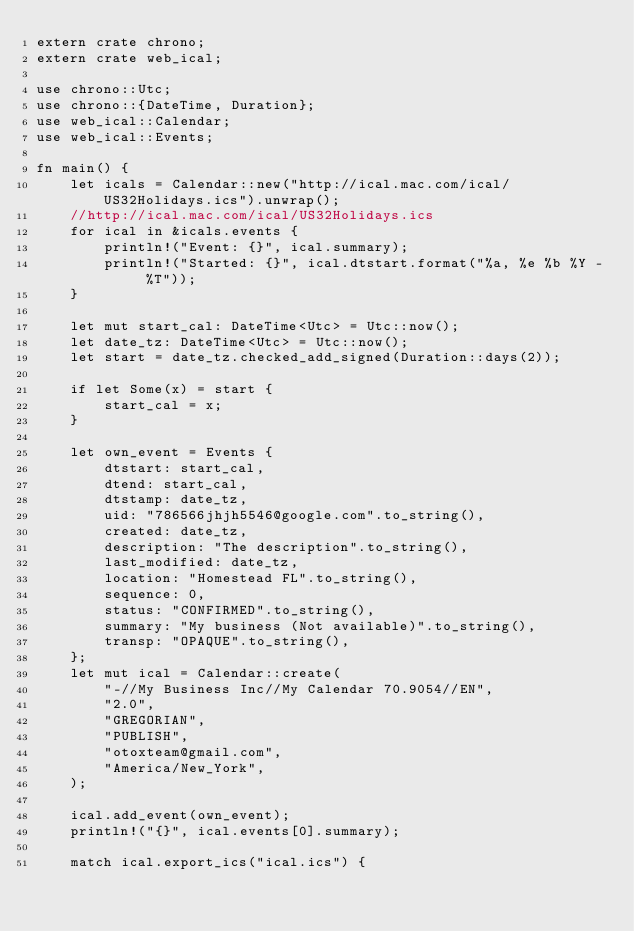<code> <loc_0><loc_0><loc_500><loc_500><_Rust_>extern crate chrono;
extern crate web_ical;

use chrono::Utc;
use chrono::{DateTime, Duration};
use web_ical::Calendar;
use web_ical::Events;

fn main() {
    let icals = Calendar::new("http://ical.mac.com/ical/US32Holidays.ics").unwrap();
    //http://ical.mac.com/ical/US32Holidays.ics
    for ical in &icals.events {
        println!("Event: {}", ical.summary);
        println!("Started: {}", ical.dtstart.format("%a, %e %b %Y - %T"));
    }

    let mut start_cal: DateTime<Utc> = Utc::now();
    let date_tz: DateTime<Utc> = Utc::now();
    let start = date_tz.checked_add_signed(Duration::days(2));

    if let Some(x) = start {
        start_cal = x;
    }

    let own_event = Events {
        dtstart: start_cal,
        dtend: start_cal,
        dtstamp: date_tz,
        uid: "786566jhjh5546@google.com".to_string(),
        created: date_tz,
        description: "The description".to_string(),
        last_modified: date_tz,
        location: "Homestead FL".to_string(),
        sequence: 0,
        status: "CONFIRMED".to_string(),
        summary: "My business (Not available)".to_string(),
        transp: "OPAQUE".to_string(),
    };
    let mut ical = Calendar::create(
        "-//My Business Inc//My Calendar 70.9054//EN",
        "2.0",
        "GREGORIAN",
        "PUBLISH",
        "otoxteam@gmail.com",
        "America/New_York",
    );

    ical.add_event(own_event);
    println!("{}", ical.events[0].summary);

    match ical.export_ics("ical.ics") {</code> 